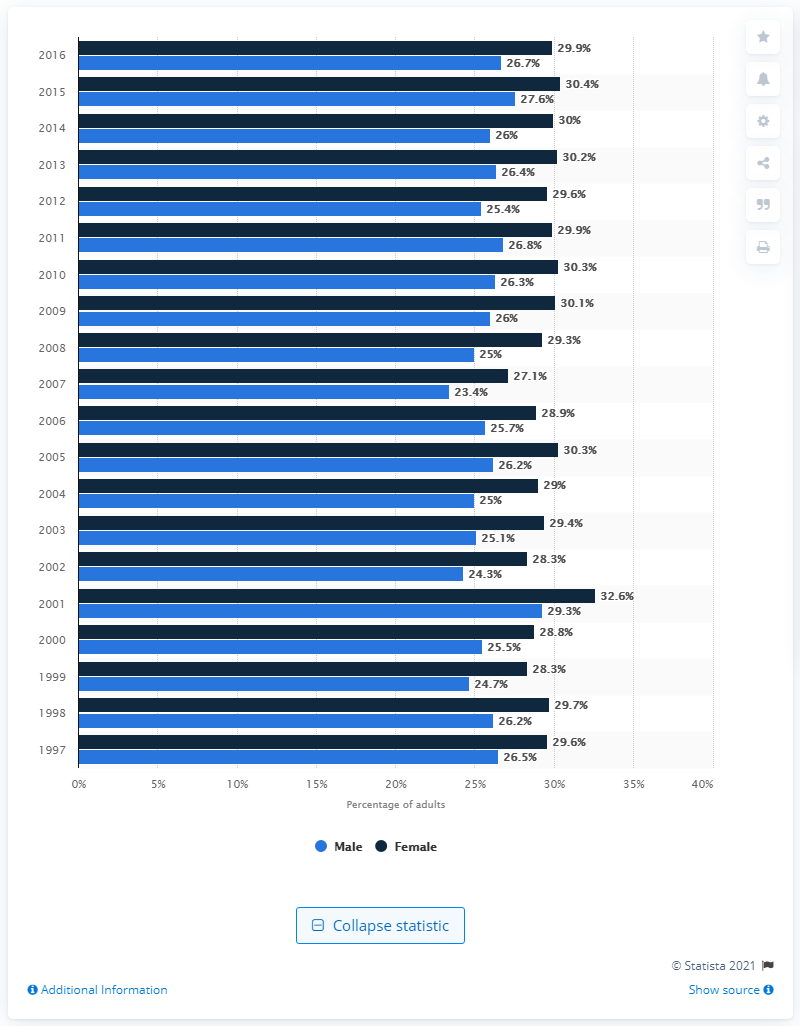List a handful of essential elements in this visual. According to a recent study, 26.7% of all male adults in the United States reported experiencing low back pain within the past three months. 